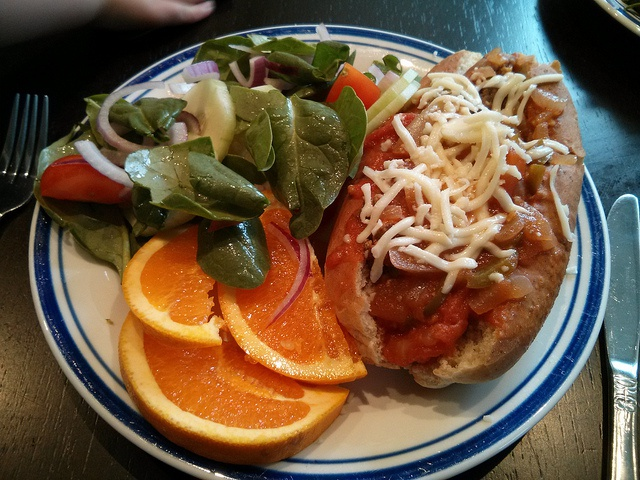Describe the objects in this image and their specific colors. I can see sandwich in gray, maroon, brown, and tan tones, orange in gray, red, brown, and orange tones, orange in gray, red, brown, and orange tones, orange in gray, red, orange, and maroon tones, and knife in gray, teal, and ivory tones in this image. 